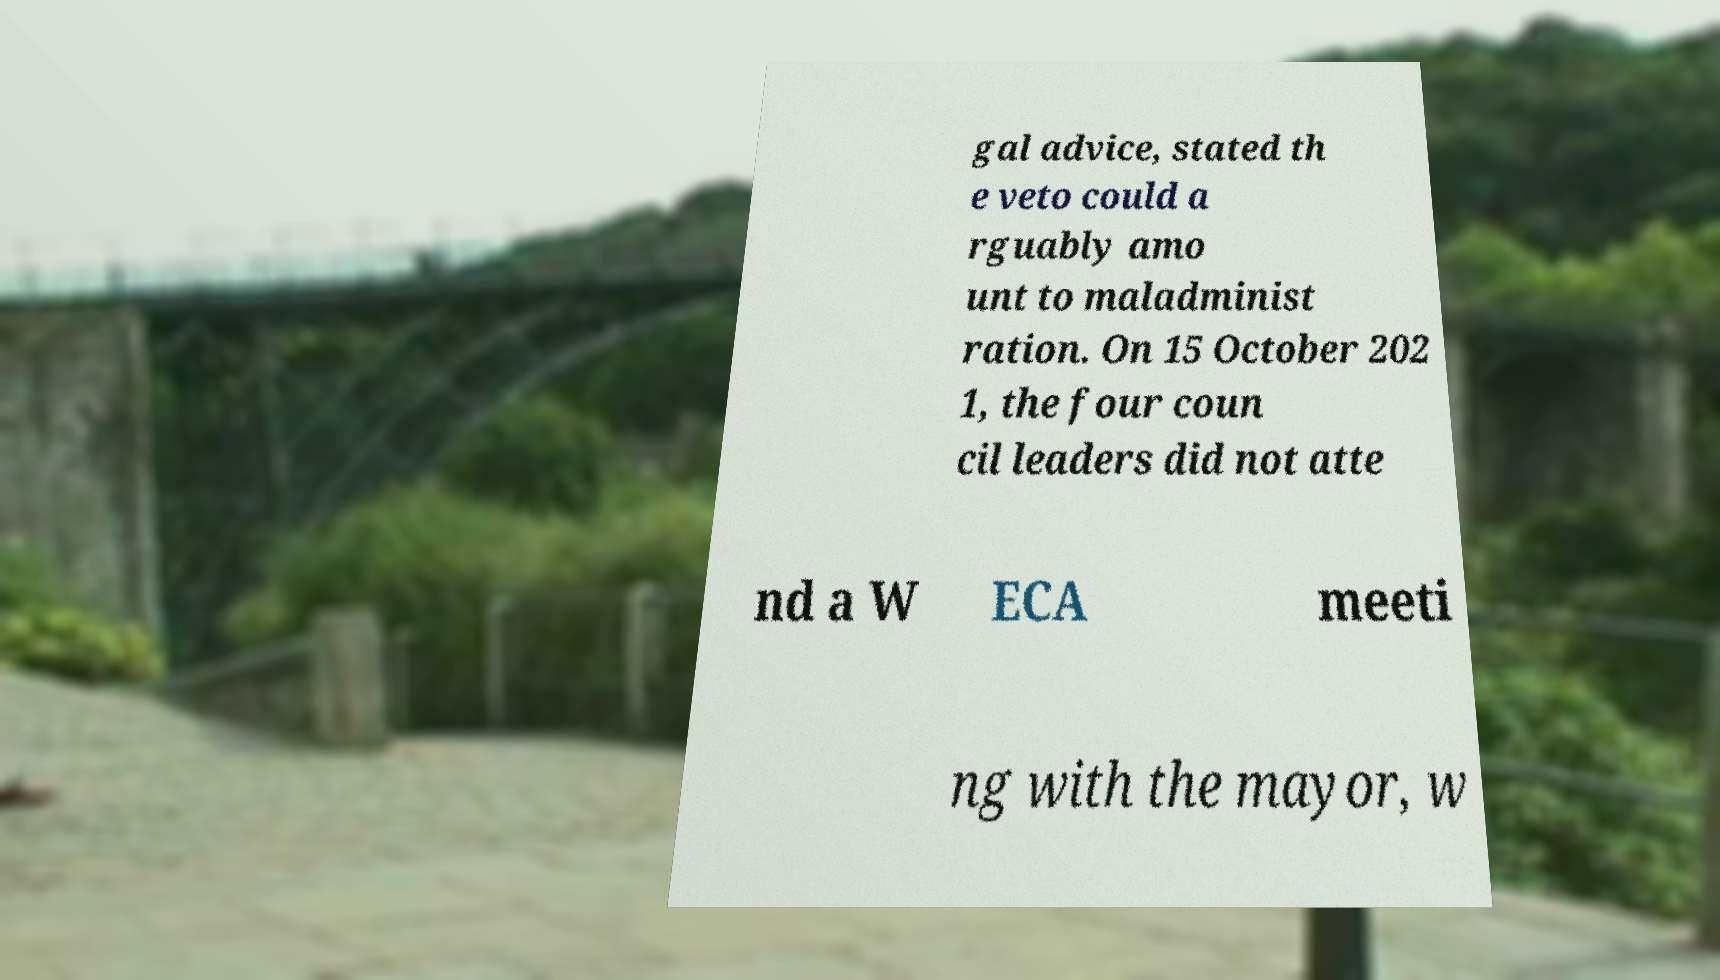I need the written content from this picture converted into text. Can you do that? gal advice, stated th e veto could a rguably amo unt to maladminist ration. On 15 October 202 1, the four coun cil leaders did not atte nd a W ECA meeti ng with the mayor, w 